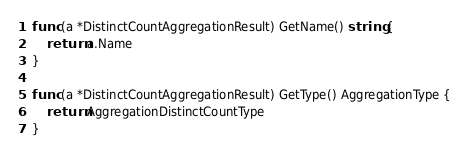Convert code to text. <code><loc_0><loc_0><loc_500><loc_500><_Go_>
func (a *DistinctCountAggregationResult) GetName() string {
	return a.Name
}

func (a *DistinctCountAggregationResult) GetType() AggregationType {
	return AggregationDistinctCountType
}</code> 